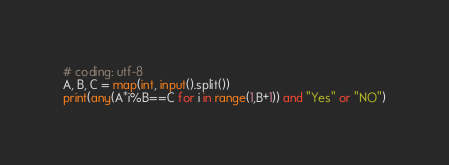Convert code to text. <code><loc_0><loc_0><loc_500><loc_500><_Python_># coding: utf-8
A, B, C = map(int, input().split())
print(any(A*i%B==C for i in range(1,B+1)) and "Yes" or "NO")</code> 